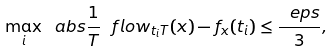<formula> <loc_0><loc_0><loc_500><loc_500>\max _ { i } \ a b s { \frac { 1 } { T } \ f l o w _ { t _ { i } T } ( x ) - f _ { x } ( t _ { i } ) } \leq \frac { \ e p s } { 3 } ,</formula> 